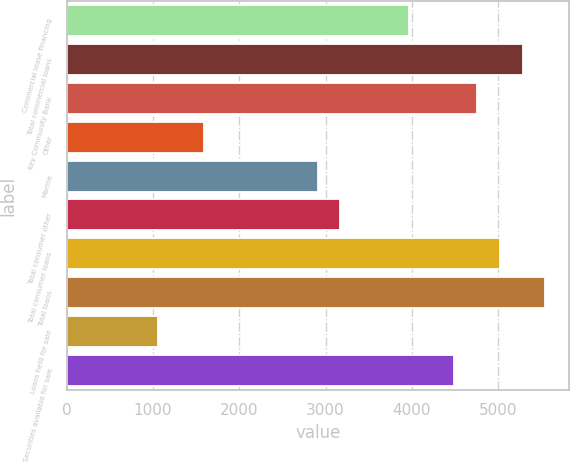Convert chart. <chart><loc_0><loc_0><loc_500><loc_500><bar_chart><fcel>Commercial lease financing<fcel>Total commercial loans<fcel>Key Community Bank<fcel>Other<fcel>Marine<fcel>Total consumer other<fcel>Total consumer loans<fcel>Total loans<fcel>Loans held for sale<fcel>Securities available for sale<nl><fcel>3964<fcel>5285<fcel>4756.6<fcel>1586.2<fcel>2907.2<fcel>3171.4<fcel>5020.8<fcel>5549.2<fcel>1057.8<fcel>4492.4<nl></chart> 